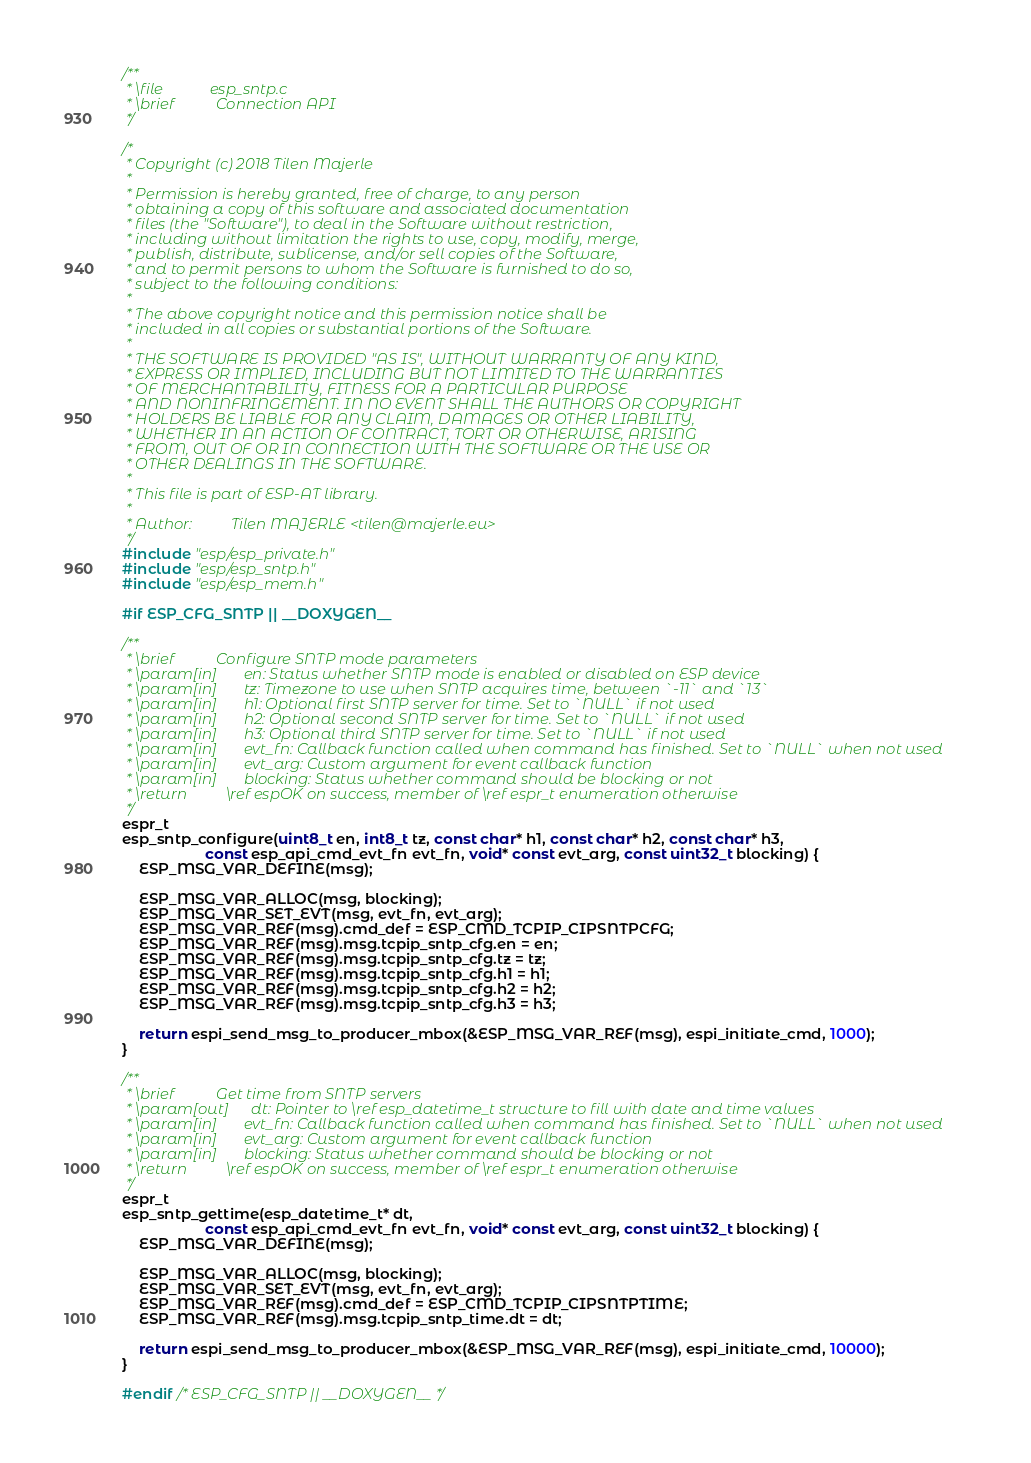Convert code to text. <code><loc_0><loc_0><loc_500><loc_500><_C_>/**
 * \file            esp_sntp.c
 * \brief           Connection API
 */

/*
 * Copyright (c) 2018 Tilen Majerle
 *
 * Permission is hereby granted, free of charge, to any person
 * obtaining a copy of this software and associated documentation
 * files (the "Software"), to deal in the Software without restriction,
 * including without limitation the rights to use, copy, modify, merge,
 * publish, distribute, sublicense, and/or sell copies of the Software,
 * and to permit persons to whom the Software is furnished to do so,
 * subject to the following conditions:
 *
 * The above copyright notice and this permission notice shall be
 * included in all copies or substantial portions of the Software.
 *
 * THE SOFTWARE IS PROVIDED "AS IS", WITHOUT WARRANTY OF ANY KIND,
 * EXPRESS OR IMPLIED, INCLUDING BUT NOT LIMITED TO THE WARRANTIES
 * OF MERCHANTABILITY, FITNESS FOR A PARTICULAR PURPOSE
 * AND NONINFRINGEMENT. IN NO EVENT SHALL THE AUTHORS OR COPYRIGHT
 * HOLDERS BE LIABLE FOR ANY CLAIM, DAMAGES OR OTHER LIABILITY,
 * WHETHER IN AN ACTION OF CONTRACT, TORT OR OTHERWISE, ARISING
 * FROM, OUT OF OR IN CONNECTION WITH THE SOFTWARE OR THE USE OR
 * OTHER DEALINGS IN THE SOFTWARE.
 *
 * This file is part of ESP-AT library.
 *
 * Author:          Tilen MAJERLE <tilen@majerle.eu>
 */
#include "esp/esp_private.h"
#include "esp/esp_sntp.h"
#include "esp/esp_mem.h"

#if ESP_CFG_SNTP || __DOXYGEN__

/**
 * \brief           Configure SNTP mode parameters
 * \param[in]       en: Status whether SNTP mode is enabled or disabled on ESP device
 * \param[in]       tz: Timezone to use when SNTP acquires time, between `-11` and `13`
 * \param[in]       h1: Optional first SNTP server for time. Set to `NULL` if not used
 * \param[in]       h2: Optional second SNTP server for time. Set to `NULL` if not used
 * \param[in]       h3: Optional third SNTP server for time. Set to `NULL` if not used
 * \param[in]       evt_fn: Callback function called when command has finished. Set to `NULL` when not used
 * \param[in]       evt_arg: Custom argument for event callback function
 * \param[in]       blocking: Status whether command should be blocking or not
 * \return          \ref espOK on success, member of \ref espr_t enumeration otherwise
 */
espr_t
esp_sntp_configure(uint8_t en, int8_t tz, const char* h1, const char* h2, const char* h3,
                    const esp_api_cmd_evt_fn evt_fn, void* const evt_arg, const uint32_t blocking) {
    ESP_MSG_VAR_DEFINE(msg);

    ESP_MSG_VAR_ALLOC(msg, blocking);
    ESP_MSG_VAR_SET_EVT(msg, evt_fn, evt_arg);
	ESP_MSG_VAR_REF(msg).cmd_def = ESP_CMD_TCPIP_CIPSNTPCFG;
    ESP_MSG_VAR_REF(msg).msg.tcpip_sntp_cfg.en = en;
    ESP_MSG_VAR_REF(msg).msg.tcpip_sntp_cfg.tz = tz;
    ESP_MSG_VAR_REF(msg).msg.tcpip_sntp_cfg.h1 = h1;
    ESP_MSG_VAR_REF(msg).msg.tcpip_sntp_cfg.h2 = h2;
    ESP_MSG_VAR_REF(msg).msg.tcpip_sntp_cfg.h3 = h3;

    return espi_send_msg_to_producer_mbox(&ESP_MSG_VAR_REF(msg), espi_initiate_cmd, 1000);
}

/**
 * \brief           Get time from SNTP servers
 * \param[out]      dt: Pointer to \ref esp_datetime_t structure to fill with date and time values
 * \param[in]       evt_fn: Callback function called when command has finished. Set to `NULL` when not used
 * \param[in]       evt_arg: Custom argument for event callback function
 * \param[in]       blocking: Status whether command should be blocking or not
 * \return          \ref espOK on success, member of \ref espr_t enumeration otherwise
 */
espr_t
esp_sntp_gettime(esp_datetime_t* dt,
                    const esp_api_cmd_evt_fn evt_fn, void* const evt_arg, const uint32_t blocking) {
    ESP_MSG_VAR_DEFINE(msg);

    ESP_MSG_VAR_ALLOC(msg, blocking);
    ESP_MSG_VAR_SET_EVT(msg, evt_fn, evt_arg);
    ESP_MSG_VAR_REF(msg).cmd_def = ESP_CMD_TCPIP_CIPSNTPTIME;
    ESP_MSG_VAR_REF(msg).msg.tcpip_sntp_time.dt = dt;

    return espi_send_msg_to_producer_mbox(&ESP_MSG_VAR_REF(msg), espi_initiate_cmd, 10000);
}

#endif /* ESP_CFG_SNTP || __DOXYGEN__ */
</code> 